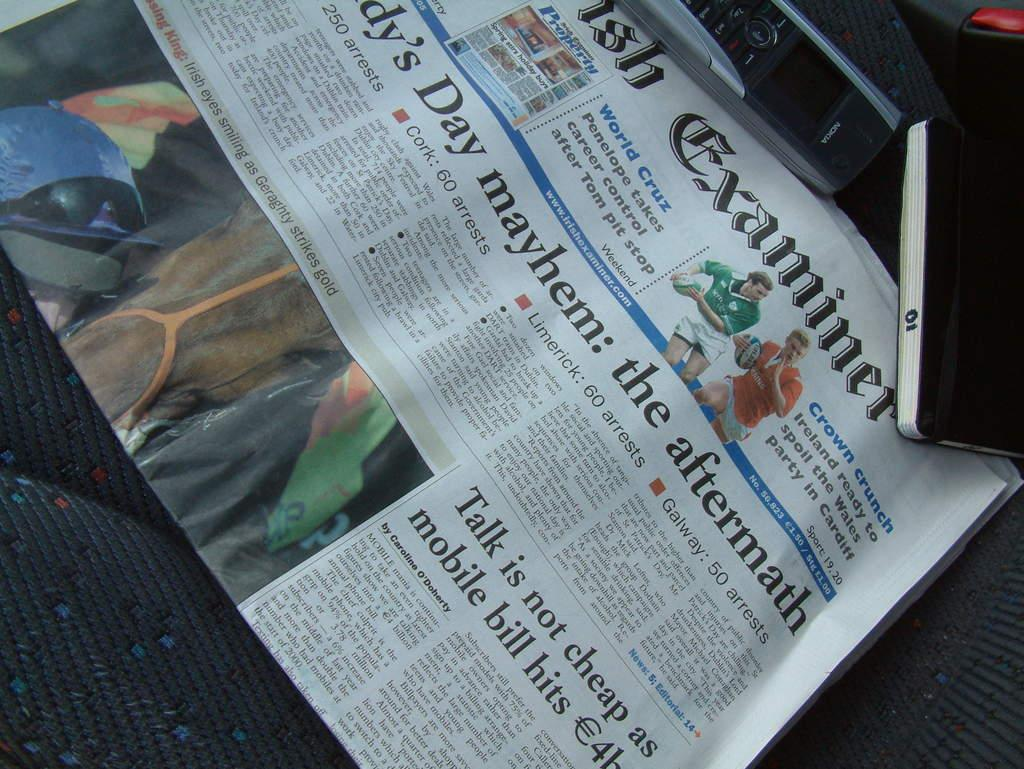<image>
Create a compact narrative representing the image presented. A newspaper says the there were 60 arrests in Cork, 60 in Limerick, and 50 in Galway, among others. 